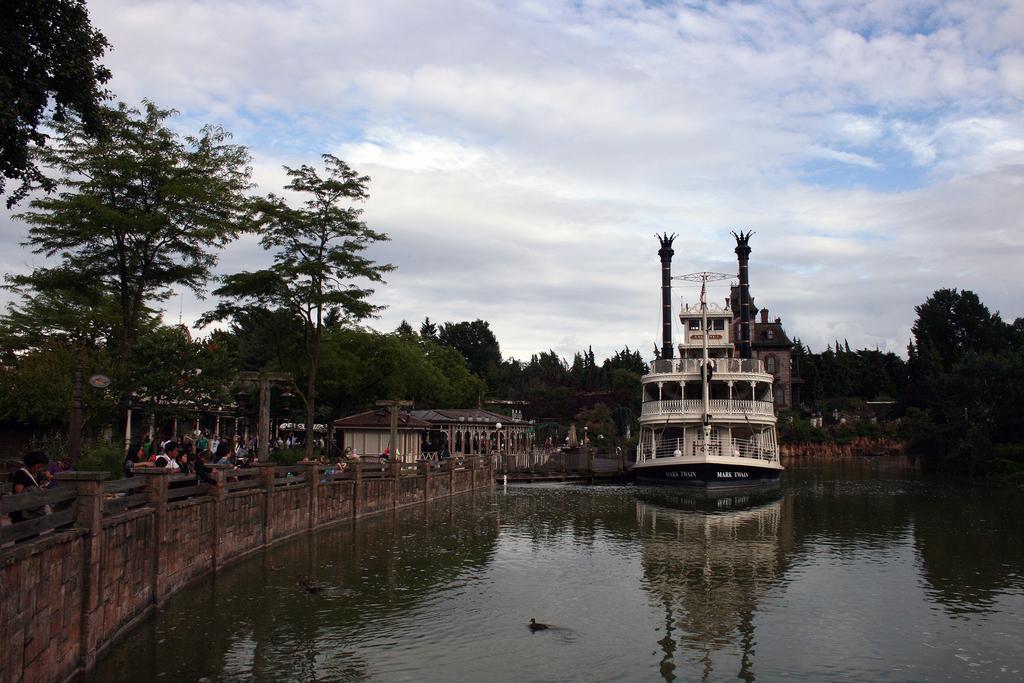Could you give a brief overview of what you see in this image? In the foreground of this picture, there is a path on which few persons are standing and there is a boat on the water. In the background, there are poles, trees, few buildings, sky and the cloud. 